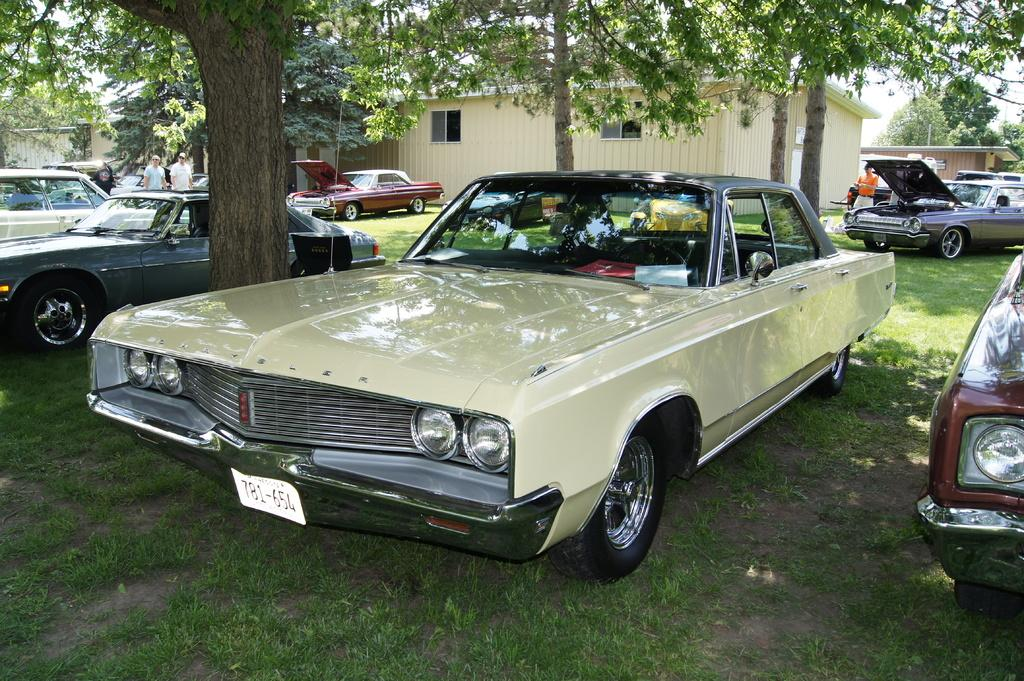What is the main subject in the center of the image? There is a group of cars in the center of the image. Can you describe the people in the image? There are people in the image, but their specific actions or positions are not mentioned in the facts. What type of terrain is visible at the bottom of the image? There is grass at the bottom of the image. What can be seen in the background of the image? There are houses and trees in the background of the image. What route are the cars taking in the image? The facts do not provide information about the cars' route or direction, so it cannot be determined from the image. 